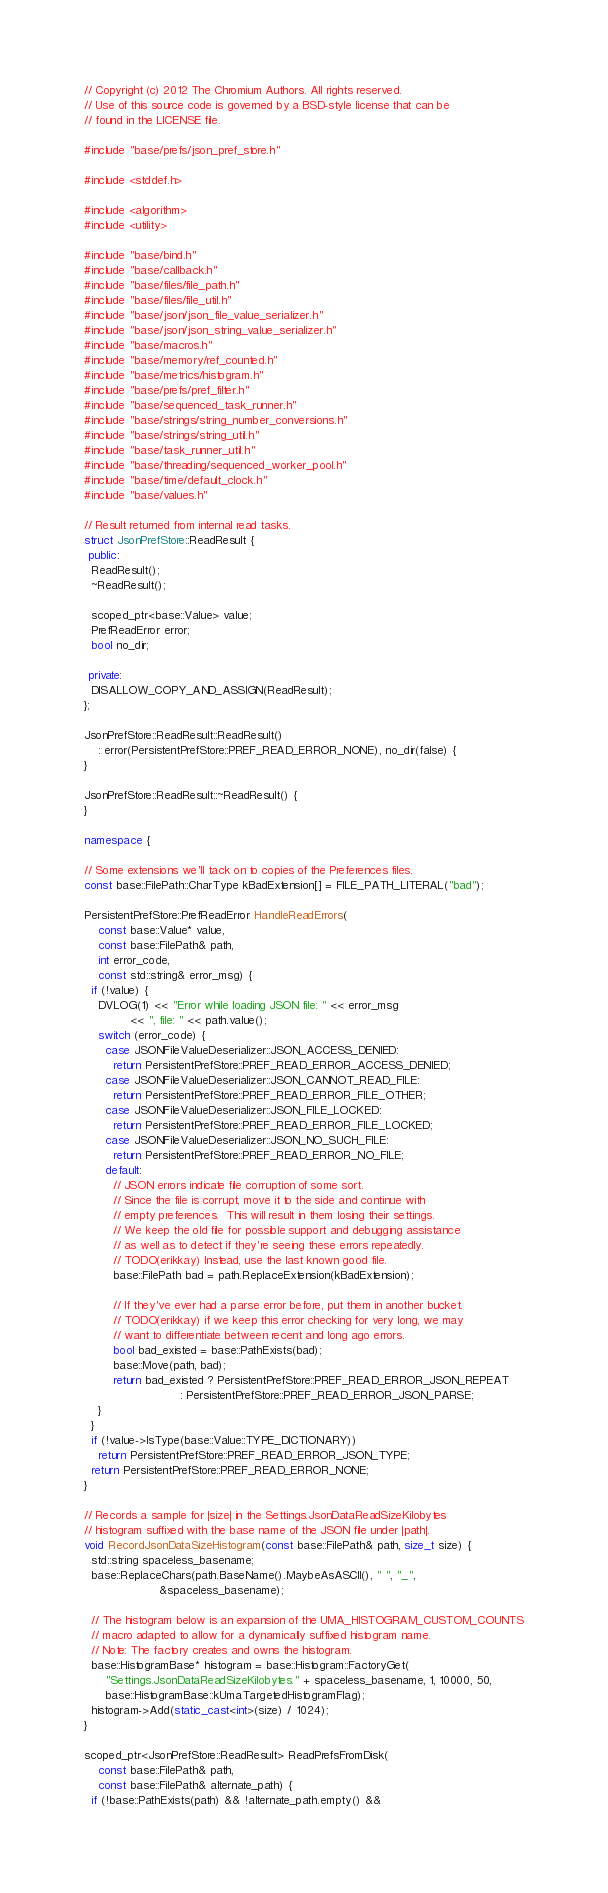<code> <loc_0><loc_0><loc_500><loc_500><_C++_>// Copyright (c) 2012 The Chromium Authors. All rights reserved.
// Use of this source code is governed by a BSD-style license that can be
// found in the LICENSE file.

#include "base/prefs/json_pref_store.h"

#include <stddef.h>

#include <algorithm>
#include <utility>

#include "base/bind.h"
#include "base/callback.h"
#include "base/files/file_path.h"
#include "base/files/file_util.h"
#include "base/json/json_file_value_serializer.h"
#include "base/json/json_string_value_serializer.h"
#include "base/macros.h"
#include "base/memory/ref_counted.h"
#include "base/metrics/histogram.h"
#include "base/prefs/pref_filter.h"
#include "base/sequenced_task_runner.h"
#include "base/strings/string_number_conversions.h"
#include "base/strings/string_util.h"
#include "base/task_runner_util.h"
#include "base/threading/sequenced_worker_pool.h"
#include "base/time/default_clock.h"
#include "base/values.h"

// Result returned from internal read tasks.
struct JsonPrefStore::ReadResult {
 public:
  ReadResult();
  ~ReadResult();

  scoped_ptr<base::Value> value;
  PrefReadError error;
  bool no_dir;

 private:
  DISALLOW_COPY_AND_ASSIGN(ReadResult);
};

JsonPrefStore::ReadResult::ReadResult()
    : error(PersistentPrefStore::PREF_READ_ERROR_NONE), no_dir(false) {
}

JsonPrefStore::ReadResult::~ReadResult() {
}

namespace {

// Some extensions we'll tack on to copies of the Preferences files.
const base::FilePath::CharType kBadExtension[] = FILE_PATH_LITERAL("bad");

PersistentPrefStore::PrefReadError HandleReadErrors(
    const base::Value* value,
    const base::FilePath& path,
    int error_code,
    const std::string& error_msg) {
  if (!value) {
    DVLOG(1) << "Error while loading JSON file: " << error_msg
             << ", file: " << path.value();
    switch (error_code) {
      case JSONFileValueDeserializer::JSON_ACCESS_DENIED:
        return PersistentPrefStore::PREF_READ_ERROR_ACCESS_DENIED;
      case JSONFileValueDeserializer::JSON_CANNOT_READ_FILE:
        return PersistentPrefStore::PREF_READ_ERROR_FILE_OTHER;
      case JSONFileValueDeserializer::JSON_FILE_LOCKED:
        return PersistentPrefStore::PREF_READ_ERROR_FILE_LOCKED;
      case JSONFileValueDeserializer::JSON_NO_SUCH_FILE:
        return PersistentPrefStore::PREF_READ_ERROR_NO_FILE;
      default:
        // JSON errors indicate file corruption of some sort.
        // Since the file is corrupt, move it to the side and continue with
        // empty preferences.  This will result in them losing their settings.
        // We keep the old file for possible support and debugging assistance
        // as well as to detect if they're seeing these errors repeatedly.
        // TODO(erikkay) Instead, use the last known good file.
        base::FilePath bad = path.ReplaceExtension(kBadExtension);

        // If they've ever had a parse error before, put them in another bucket.
        // TODO(erikkay) if we keep this error checking for very long, we may
        // want to differentiate between recent and long ago errors.
        bool bad_existed = base::PathExists(bad);
        base::Move(path, bad);
        return bad_existed ? PersistentPrefStore::PREF_READ_ERROR_JSON_REPEAT
                           : PersistentPrefStore::PREF_READ_ERROR_JSON_PARSE;
    }
  }
  if (!value->IsType(base::Value::TYPE_DICTIONARY))
    return PersistentPrefStore::PREF_READ_ERROR_JSON_TYPE;
  return PersistentPrefStore::PREF_READ_ERROR_NONE;
}

// Records a sample for |size| in the Settings.JsonDataReadSizeKilobytes
// histogram suffixed with the base name of the JSON file under |path|.
void RecordJsonDataSizeHistogram(const base::FilePath& path, size_t size) {
  std::string spaceless_basename;
  base::ReplaceChars(path.BaseName().MaybeAsASCII(), " ", "_",
                     &spaceless_basename);

  // The histogram below is an expansion of the UMA_HISTOGRAM_CUSTOM_COUNTS
  // macro adapted to allow for a dynamically suffixed histogram name.
  // Note: The factory creates and owns the histogram.
  base::HistogramBase* histogram = base::Histogram::FactoryGet(
      "Settings.JsonDataReadSizeKilobytes." + spaceless_basename, 1, 10000, 50,
      base::HistogramBase::kUmaTargetedHistogramFlag);
  histogram->Add(static_cast<int>(size) / 1024);
}

scoped_ptr<JsonPrefStore::ReadResult> ReadPrefsFromDisk(
    const base::FilePath& path,
    const base::FilePath& alternate_path) {
  if (!base::PathExists(path) && !alternate_path.empty() &&</code> 